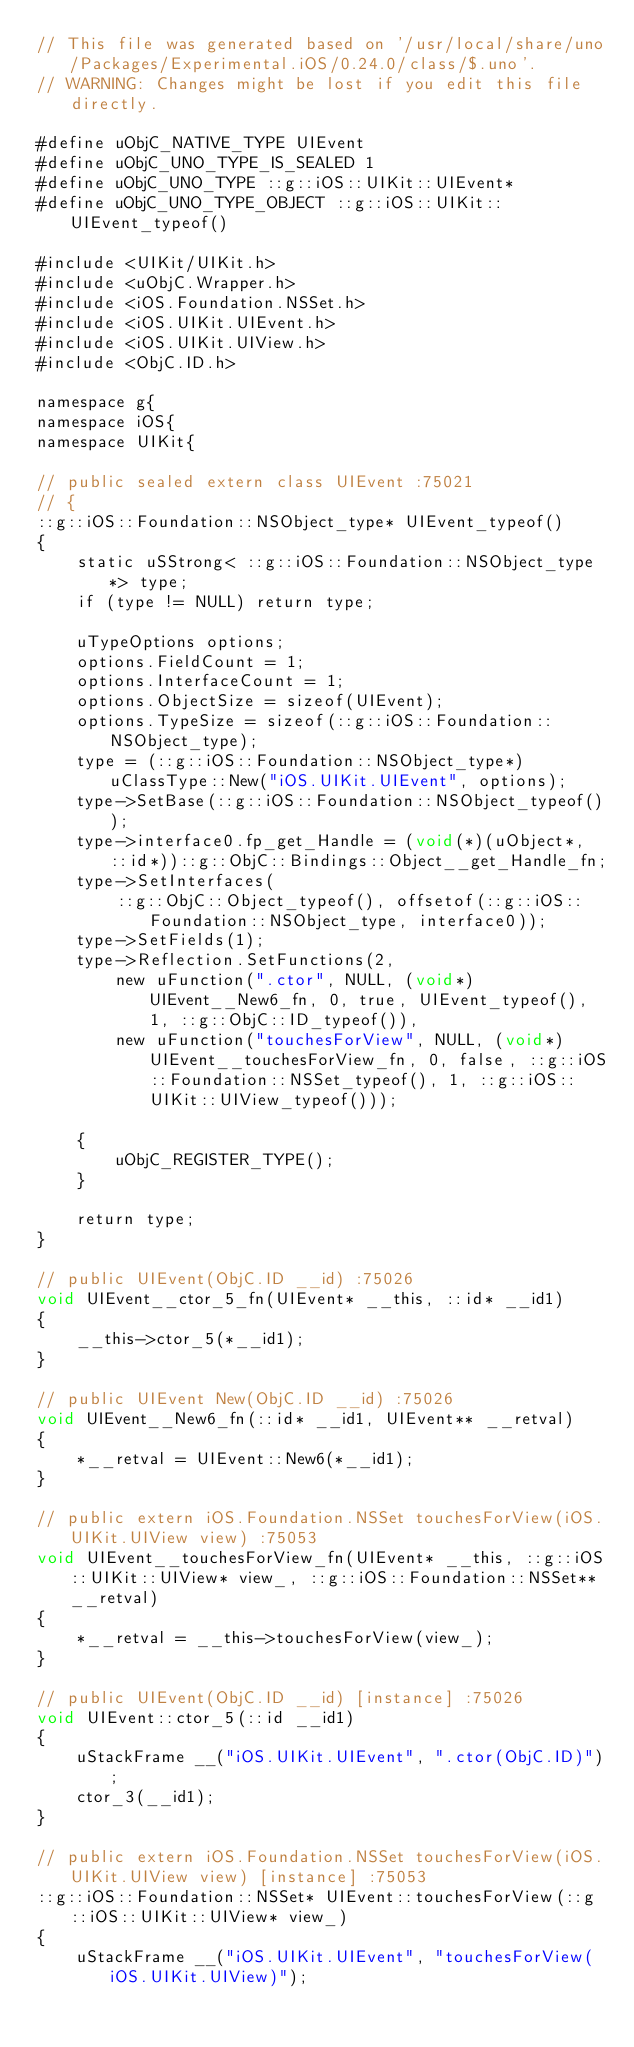<code> <loc_0><loc_0><loc_500><loc_500><_ObjectiveC_>// This file was generated based on '/usr/local/share/uno/Packages/Experimental.iOS/0.24.0/class/$.uno'.
// WARNING: Changes might be lost if you edit this file directly.

#define uObjC_NATIVE_TYPE UIEvent
#define uObjC_UNO_TYPE_IS_SEALED 1
#define uObjC_UNO_TYPE ::g::iOS::UIKit::UIEvent*
#define uObjC_UNO_TYPE_OBJECT ::g::iOS::UIKit::UIEvent_typeof()

#include <UIKit/UIKit.h>
#include <uObjC.Wrapper.h>
#include <iOS.Foundation.NSSet.h>
#include <iOS.UIKit.UIEvent.h>
#include <iOS.UIKit.UIView.h>
#include <ObjC.ID.h>

namespace g{
namespace iOS{
namespace UIKit{

// public sealed extern class UIEvent :75021
// {
::g::iOS::Foundation::NSObject_type* UIEvent_typeof()
{
    static uSStrong< ::g::iOS::Foundation::NSObject_type*> type;
    if (type != NULL) return type;

    uTypeOptions options;
    options.FieldCount = 1;
    options.InterfaceCount = 1;
    options.ObjectSize = sizeof(UIEvent);
    options.TypeSize = sizeof(::g::iOS::Foundation::NSObject_type);
    type = (::g::iOS::Foundation::NSObject_type*)uClassType::New("iOS.UIKit.UIEvent", options);
    type->SetBase(::g::iOS::Foundation::NSObject_typeof());
    type->interface0.fp_get_Handle = (void(*)(uObject*, ::id*))::g::ObjC::Bindings::Object__get_Handle_fn;
    type->SetInterfaces(
        ::g::ObjC::Object_typeof(), offsetof(::g::iOS::Foundation::NSObject_type, interface0));
    type->SetFields(1);
    type->Reflection.SetFunctions(2,
        new uFunction(".ctor", NULL, (void*)UIEvent__New6_fn, 0, true, UIEvent_typeof(), 1, ::g::ObjC::ID_typeof()),
        new uFunction("touchesForView", NULL, (void*)UIEvent__touchesForView_fn, 0, false, ::g::iOS::Foundation::NSSet_typeof(), 1, ::g::iOS::UIKit::UIView_typeof()));

    {
        uObjC_REGISTER_TYPE();
    }

    return type;
}

// public UIEvent(ObjC.ID __id) :75026
void UIEvent__ctor_5_fn(UIEvent* __this, ::id* __id1)
{
    __this->ctor_5(*__id1);
}

// public UIEvent New(ObjC.ID __id) :75026
void UIEvent__New6_fn(::id* __id1, UIEvent** __retval)
{
    *__retval = UIEvent::New6(*__id1);
}

// public extern iOS.Foundation.NSSet touchesForView(iOS.UIKit.UIView view) :75053
void UIEvent__touchesForView_fn(UIEvent* __this, ::g::iOS::UIKit::UIView* view_, ::g::iOS::Foundation::NSSet** __retval)
{
    *__retval = __this->touchesForView(view_);
}

// public UIEvent(ObjC.ID __id) [instance] :75026
void UIEvent::ctor_5(::id __id1)
{
    uStackFrame __("iOS.UIKit.UIEvent", ".ctor(ObjC.ID)");
    ctor_3(__id1);
}

// public extern iOS.Foundation.NSSet touchesForView(iOS.UIKit.UIView view) [instance] :75053
::g::iOS::Foundation::NSSet* UIEvent::touchesForView(::g::iOS::UIKit::UIView* view_)
{
    uStackFrame __("iOS.UIKit.UIEvent", "touchesForView(iOS.UIKit.UIView)");</code> 